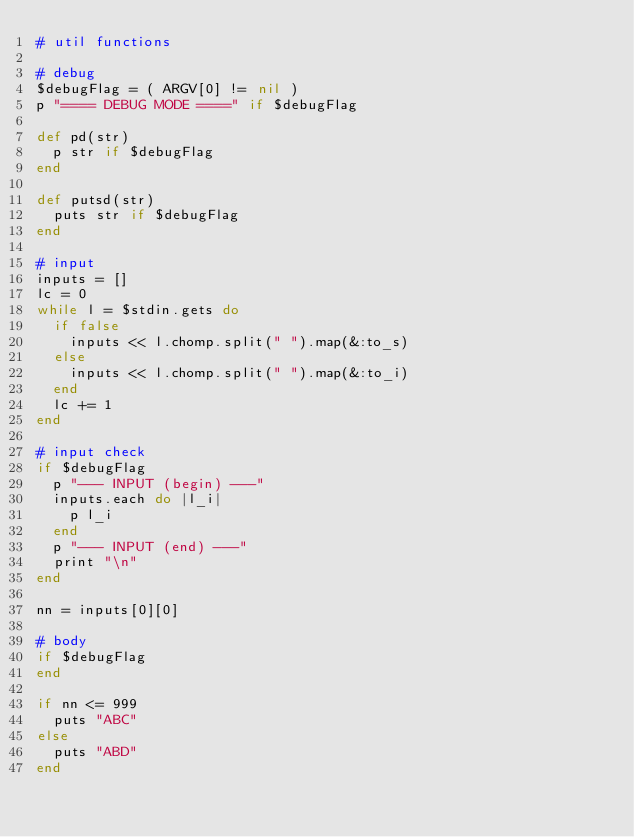Convert code to text. <code><loc_0><loc_0><loc_500><loc_500><_Ruby_># util functions

# debug
$debugFlag = ( ARGV[0] != nil )
p "==== DEBUG MODE ====" if $debugFlag

def pd(str)
  p str if $debugFlag
end

def putsd(str)
  puts str if $debugFlag
end

# input
inputs = []
lc = 0
while l = $stdin.gets do
  if false
    inputs << l.chomp.split(" ").map(&:to_s)
  else
    inputs << l.chomp.split(" ").map(&:to_i)
  end
  lc += 1
end

# input check
if $debugFlag
  p "--- INPUT (begin) ---"
  inputs.each do |l_i|
    p l_i
  end
  p "--- INPUT (end) ---"
  print "\n"
end

nn = inputs[0][0]

# body
if $debugFlag
end

if nn <= 999
  puts "ABC"
else
  puts "ABD"
end</code> 